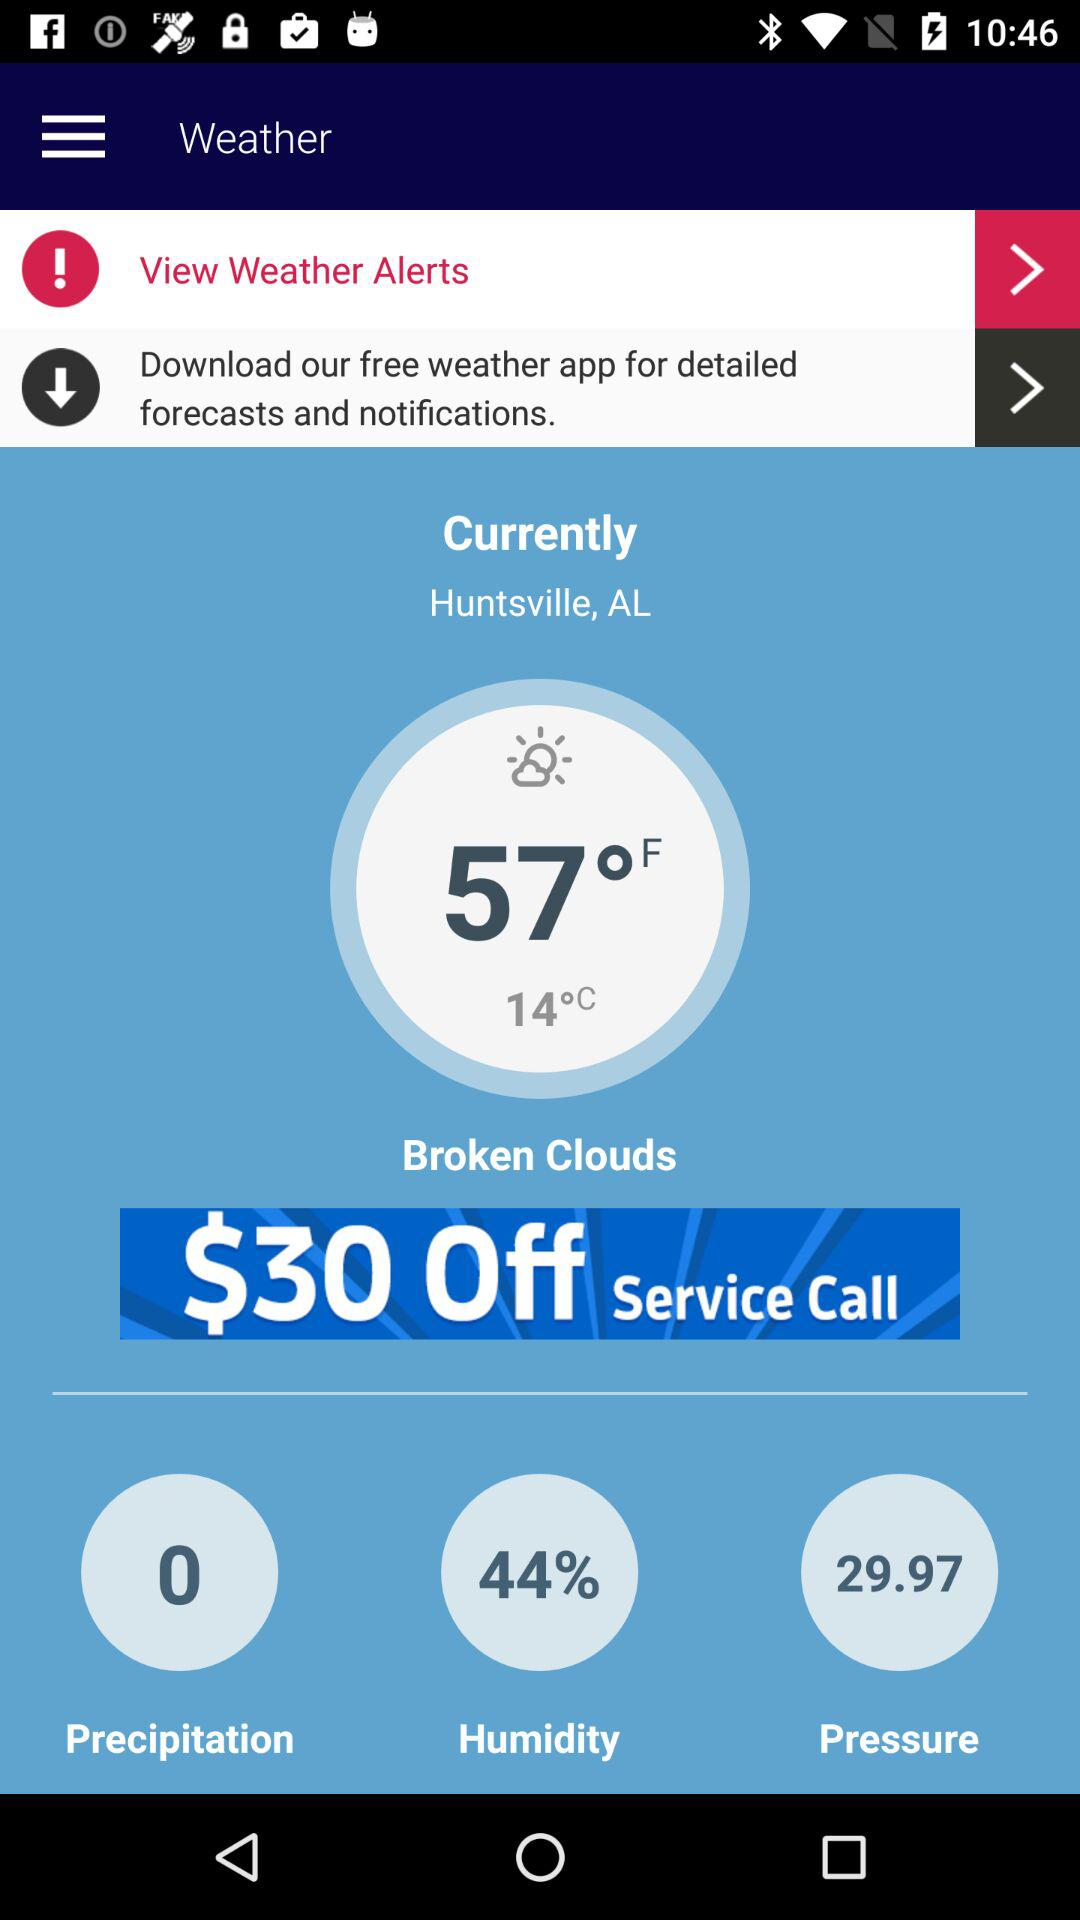What is the current temperature in celsius? The temperature is 14° Celsius. 